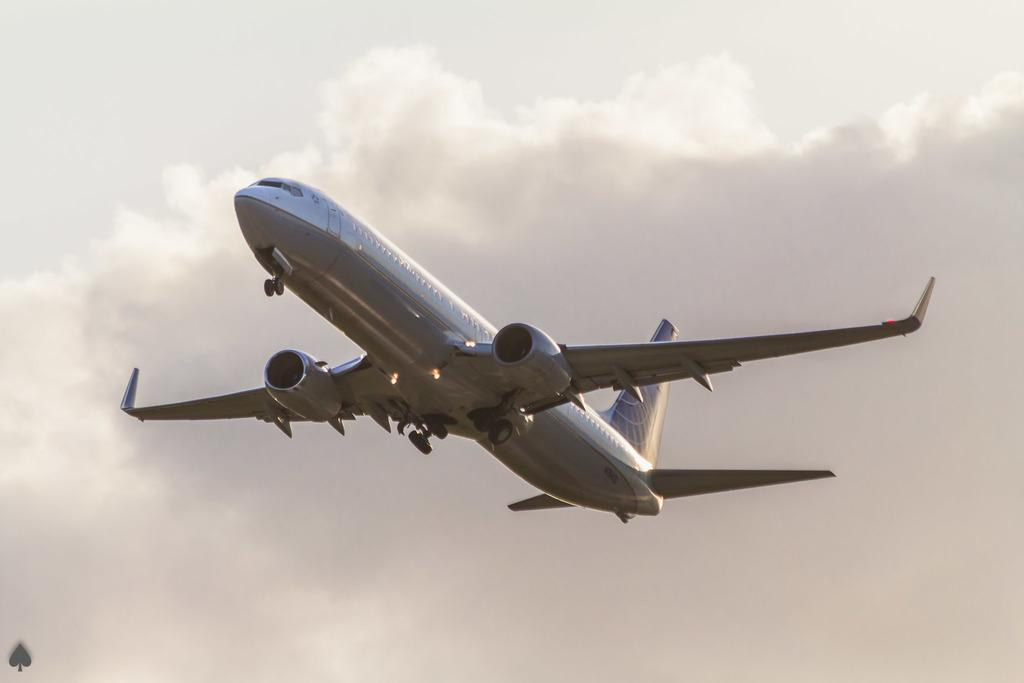What is the main subject of the image? The main subject of the image is an airplane. Can you describe the position of the airplane in the image? The airplane is in the air in the image. What can be seen in the background of the image? There are clouds and the sky visible in the background of the image. What is the taste of the neck in the image? There is no neck present in the image, and therefore no taste can be determined. 